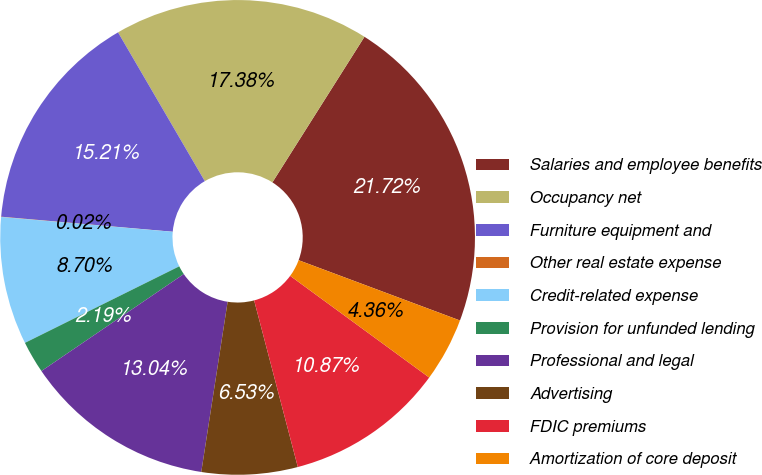<chart> <loc_0><loc_0><loc_500><loc_500><pie_chart><fcel>Salaries and employee benefits<fcel>Occupancy net<fcel>Furniture equipment and<fcel>Other real estate expense<fcel>Credit-related expense<fcel>Provision for unfunded lending<fcel>Professional and legal<fcel>Advertising<fcel>FDIC premiums<fcel>Amortization of core deposit<nl><fcel>21.72%<fcel>17.38%<fcel>15.21%<fcel>0.02%<fcel>8.7%<fcel>2.19%<fcel>13.04%<fcel>6.53%<fcel>10.87%<fcel>4.36%<nl></chart> 